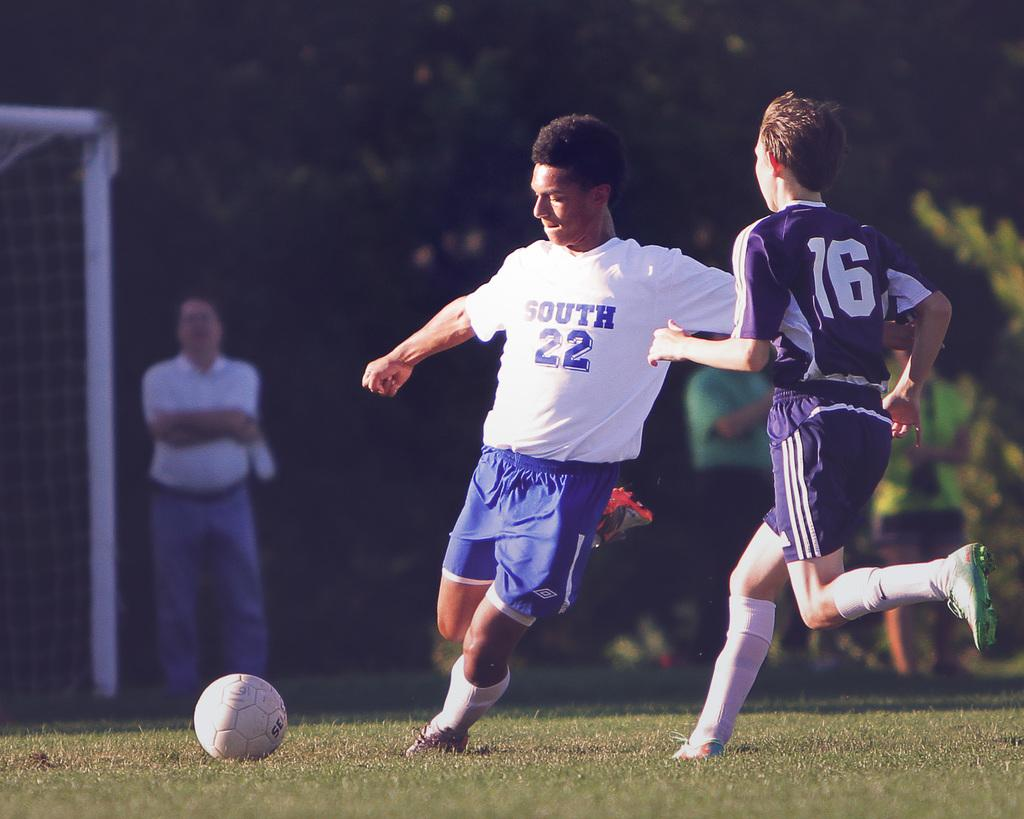<image>
Offer a succinct explanation of the picture presented. A soccer player has number 22 on his shirt. 